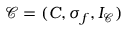Convert formula to latex. <formula><loc_0><loc_0><loc_500><loc_500>{ \mathcal { C } } = ( C , \sigma _ { f } , I _ { \mathcal { C } } )</formula> 